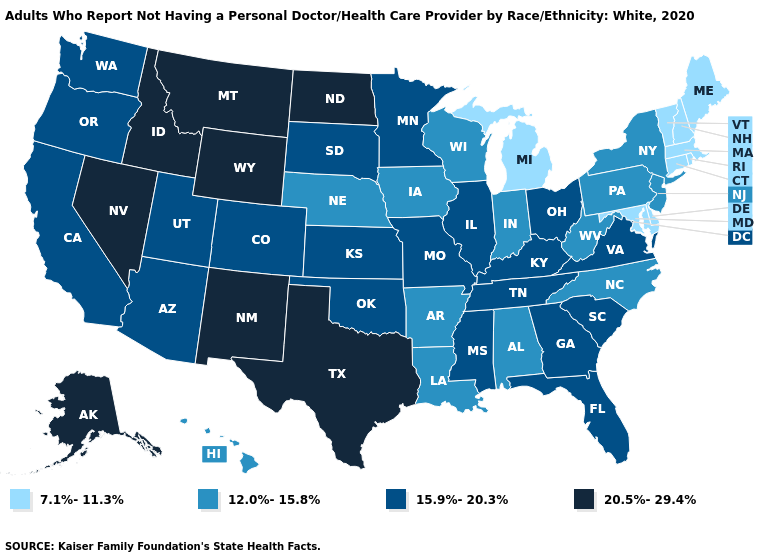Among the states that border Massachusetts , which have the lowest value?
Quick response, please. Connecticut, New Hampshire, Rhode Island, Vermont. Does Alaska have the highest value in the West?
Give a very brief answer. Yes. Among the states that border Connecticut , does New York have the highest value?
Quick response, please. Yes. What is the lowest value in the USA?
Concise answer only. 7.1%-11.3%. Among the states that border Illinois , which have the lowest value?
Quick response, please. Indiana, Iowa, Wisconsin. What is the lowest value in states that border Colorado?
Give a very brief answer. 12.0%-15.8%. How many symbols are there in the legend?
Answer briefly. 4. What is the value of Kentucky?
Short answer required. 15.9%-20.3%. Which states have the lowest value in the USA?
Answer briefly. Connecticut, Delaware, Maine, Maryland, Massachusetts, Michigan, New Hampshire, Rhode Island, Vermont. Does Nevada have a higher value than Wisconsin?
Write a very short answer. Yes. What is the highest value in states that border Oklahoma?
Give a very brief answer. 20.5%-29.4%. Does Nevada have the lowest value in the West?
Be succinct. No. Does Vermont have a lower value than Wisconsin?
Quick response, please. Yes. Does the map have missing data?
Answer briefly. No. Name the states that have a value in the range 7.1%-11.3%?
Answer briefly. Connecticut, Delaware, Maine, Maryland, Massachusetts, Michigan, New Hampshire, Rhode Island, Vermont. 